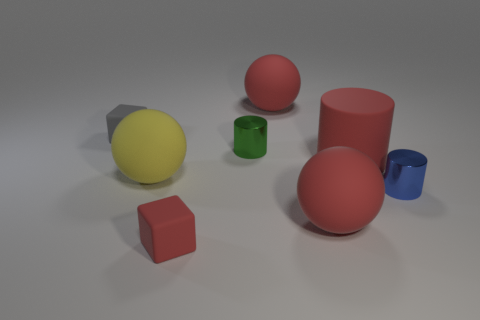What size is the blue cylinder that is the same material as the tiny green cylinder?
Provide a short and direct response. Small. What is the shape of the object that is behind the green object and right of the gray object?
Provide a short and direct response. Sphere. The red thing that is the same shape as the small blue thing is what size?
Make the answer very short. Large. Is the number of yellow things that are in front of the gray rubber block less than the number of blue cylinders?
Offer a terse response. No. What is the size of the sphere that is left of the red cube?
Your answer should be compact. Large. The other rubber thing that is the same shape as the tiny gray matte thing is what color?
Keep it short and to the point. Red. What number of tiny metal cylinders are the same color as the big rubber cylinder?
Give a very brief answer. 0. There is a small cylinder that is on the right side of the large red matte ball that is behind the yellow rubber sphere; are there any small objects that are behind it?
Give a very brief answer. Yes. What number of things have the same material as the green cylinder?
Your response must be concise. 1. There is a yellow thing behind the red cube; is its size the same as the red block in front of the yellow rubber thing?
Provide a short and direct response. No. 